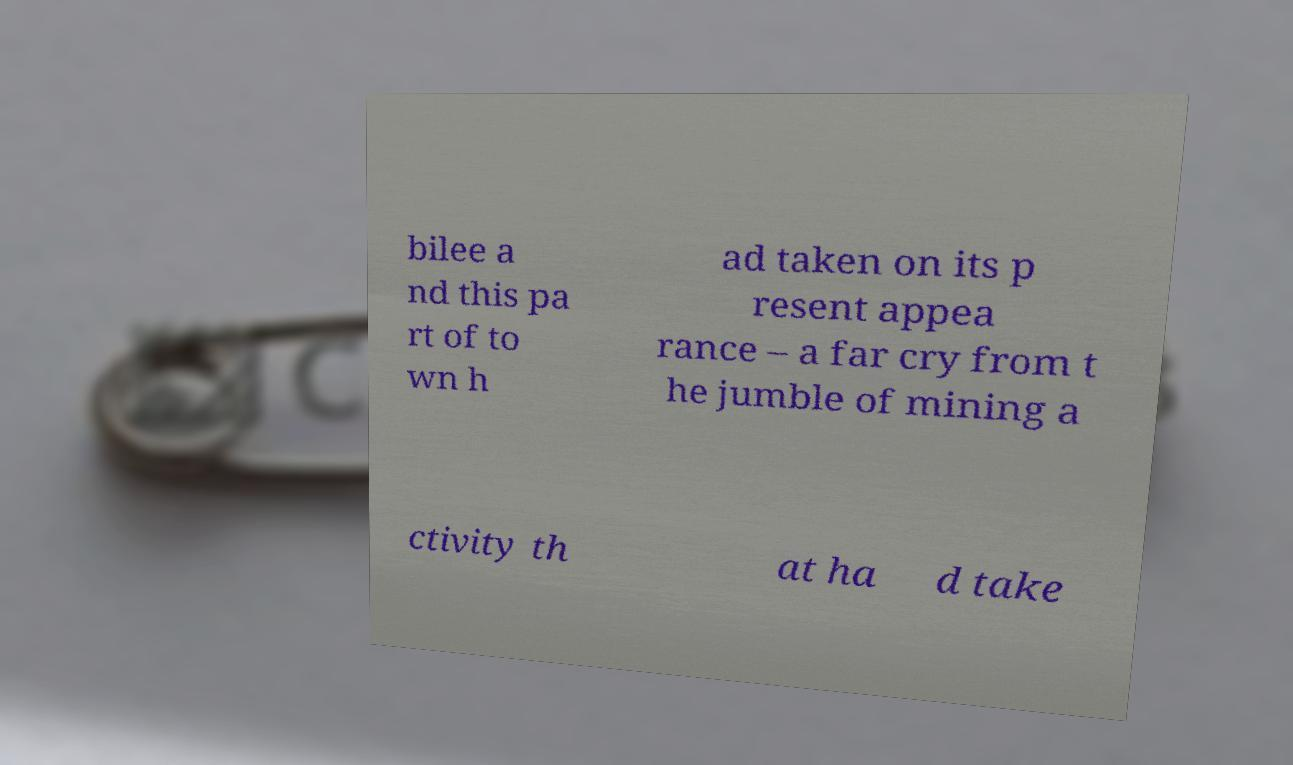There's text embedded in this image that I need extracted. Can you transcribe it verbatim? bilee a nd this pa rt of to wn h ad taken on its p resent appea rance – a far cry from t he jumble of mining a ctivity th at ha d take 